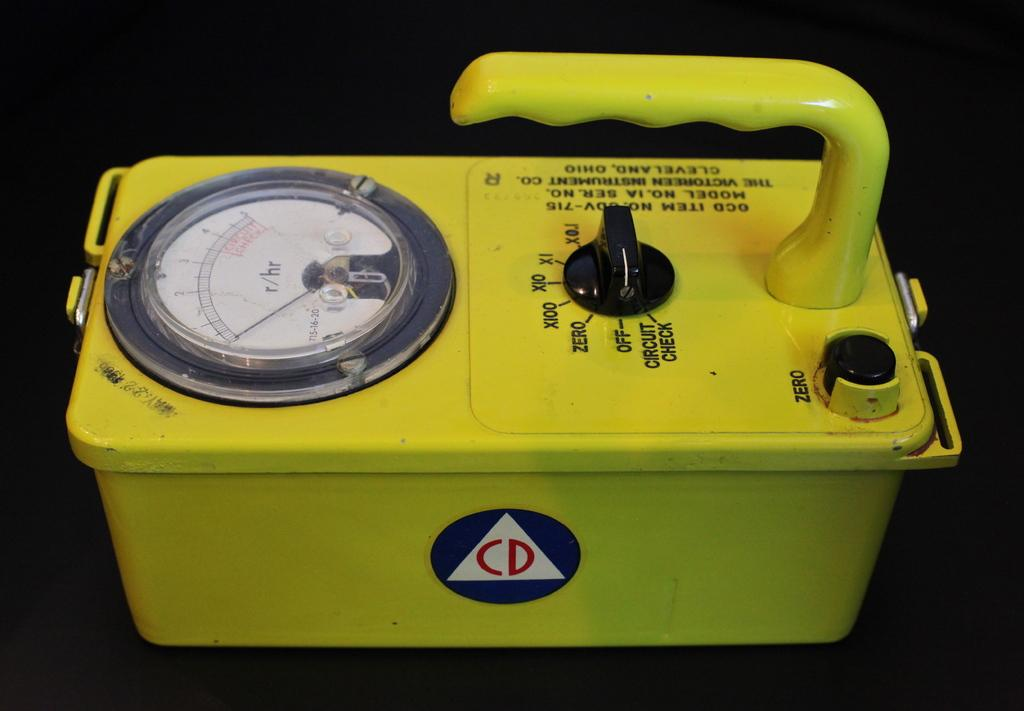What is the main object in the image? There is a victoreen instrument in the image. What is the color of the surface on which the victoreen instrument is placed? The victoreen instrument is on a black color surface. What type of army is present in the image? There is no army present in the image; it features a victoreen instrument on a black surface. What type of kittens can be seen interacting with the victoreen instrument in the image? There are no kittens present in the image, and therefore no such interaction can be observed. 